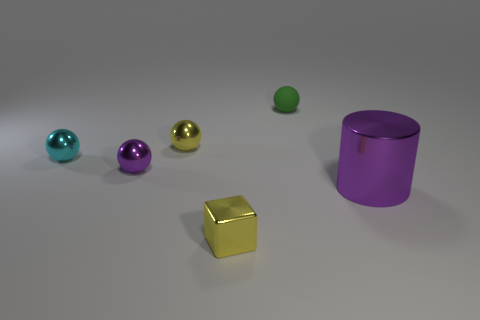What time of day does the lighting suggest in this scene? The even and soft lighting in the image suggests an artificial or studio light source rather than natural sunlight, which means it does not imply a particular time of day. 